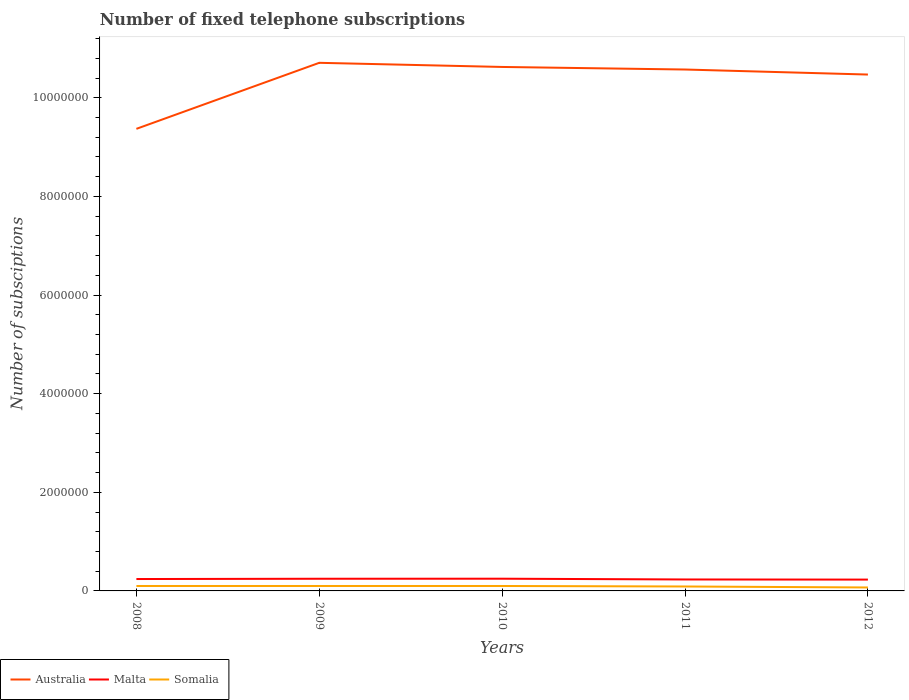How many different coloured lines are there?
Give a very brief answer. 3. Is the number of lines equal to the number of legend labels?
Make the answer very short. Yes. Across all years, what is the maximum number of fixed telephone subscriptions in Australia?
Provide a succinct answer. 9.37e+06. In which year was the number of fixed telephone subscriptions in Australia maximum?
Your response must be concise. 2008. What is the total number of fixed telephone subscriptions in Malta in the graph?
Keep it short and to the point. 1.72e+04. What is the difference between the highest and the second highest number of fixed telephone subscriptions in Malta?
Offer a terse response. 1.79e+04. What is the difference between the highest and the lowest number of fixed telephone subscriptions in Australia?
Your answer should be compact. 4. Is the number of fixed telephone subscriptions in Malta strictly greater than the number of fixed telephone subscriptions in Australia over the years?
Your response must be concise. Yes. How many years are there in the graph?
Make the answer very short. 5. What is the difference between two consecutive major ticks on the Y-axis?
Provide a short and direct response. 2.00e+06. Does the graph contain any zero values?
Your answer should be compact. No. What is the title of the graph?
Offer a very short reply. Number of fixed telephone subscriptions. What is the label or title of the X-axis?
Offer a terse response. Years. What is the label or title of the Y-axis?
Keep it short and to the point. Number of subsciptions. What is the Number of subsciptions in Australia in 2008?
Give a very brief answer. 9.37e+06. What is the Number of subsciptions in Malta in 2008?
Provide a succinct answer. 2.41e+05. What is the Number of subsciptions in Somalia in 2008?
Make the answer very short. 1.00e+05. What is the Number of subsciptions in Australia in 2009?
Ensure brevity in your answer.  1.07e+07. What is the Number of subsciptions in Malta in 2009?
Offer a terse response. 2.47e+05. What is the Number of subsciptions in Somalia in 2009?
Ensure brevity in your answer.  1.00e+05. What is the Number of subsciptions of Australia in 2010?
Your response must be concise. 1.06e+07. What is the Number of subsciptions in Malta in 2010?
Your answer should be very brief. 2.48e+05. What is the Number of subsciptions in Somalia in 2010?
Provide a succinct answer. 1.00e+05. What is the Number of subsciptions of Australia in 2011?
Provide a short and direct response. 1.06e+07. What is the Number of subsciptions in Malta in 2011?
Give a very brief answer. 2.32e+05. What is the Number of subsciptions of Australia in 2012?
Give a very brief answer. 1.05e+07. What is the Number of subsciptions of Malta in 2012?
Make the answer very short. 2.30e+05. What is the Number of subsciptions of Somalia in 2012?
Make the answer very short. 7.00e+04. Across all years, what is the maximum Number of subsciptions in Australia?
Provide a short and direct response. 1.07e+07. Across all years, what is the maximum Number of subsciptions of Malta?
Offer a very short reply. 2.48e+05. Across all years, what is the maximum Number of subsciptions of Somalia?
Offer a very short reply. 1.00e+05. Across all years, what is the minimum Number of subsciptions in Australia?
Keep it short and to the point. 9.37e+06. Across all years, what is the minimum Number of subsciptions of Malta?
Your response must be concise. 2.30e+05. What is the total Number of subsciptions in Australia in the graph?
Offer a terse response. 5.17e+07. What is the total Number of subsciptions of Malta in the graph?
Ensure brevity in your answer.  1.20e+06. What is the total Number of subsciptions in Somalia in the graph?
Your response must be concise. 4.60e+05. What is the difference between the Number of subsciptions in Australia in 2008 and that in 2009?
Provide a short and direct response. -1.34e+06. What is the difference between the Number of subsciptions in Malta in 2008 and that in 2009?
Offer a very short reply. -5775. What is the difference between the Number of subsciptions of Australia in 2008 and that in 2010?
Offer a very short reply. -1.26e+06. What is the difference between the Number of subsciptions of Malta in 2008 and that in 2010?
Make the answer very short. -6520. What is the difference between the Number of subsciptions in Australia in 2008 and that in 2011?
Offer a terse response. -1.20e+06. What is the difference between the Number of subsciptions of Malta in 2008 and that in 2011?
Your answer should be very brief. 8912. What is the difference between the Number of subsciptions of Somalia in 2008 and that in 2011?
Your answer should be very brief. 10000. What is the difference between the Number of subsciptions in Australia in 2008 and that in 2012?
Your answer should be very brief. -1.10e+06. What is the difference between the Number of subsciptions in Malta in 2008 and that in 2012?
Give a very brief answer. 1.14e+04. What is the difference between the Number of subsciptions of Somalia in 2008 and that in 2012?
Your response must be concise. 3.00e+04. What is the difference between the Number of subsciptions in Australia in 2009 and that in 2010?
Your answer should be compact. 8.40e+04. What is the difference between the Number of subsciptions in Malta in 2009 and that in 2010?
Provide a succinct answer. -745. What is the difference between the Number of subsciptions in Australia in 2009 and that in 2011?
Provide a succinct answer. 1.36e+05. What is the difference between the Number of subsciptions in Malta in 2009 and that in 2011?
Your response must be concise. 1.47e+04. What is the difference between the Number of subsciptions of Somalia in 2009 and that in 2011?
Give a very brief answer. 10000. What is the difference between the Number of subsciptions of Australia in 2009 and that in 2012?
Your answer should be compact. 2.38e+05. What is the difference between the Number of subsciptions of Malta in 2009 and that in 2012?
Keep it short and to the point. 1.72e+04. What is the difference between the Number of subsciptions in Australia in 2010 and that in 2011?
Offer a very short reply. 5.20e+04. What is the difference between the Number of subsciptions of Malta in 2010 and that in 2011?
Your answer should be compact. 1.54e+04. What is the difference between the Number of subsciptions in Australia in 2010 and that in 2012?
Provide a short and direct response. 1.54e+05. What is the difference between the Number of subsciptions of Malta in 2010 and that in 2012?
Your answer should be compact. 1.79e+04. What is the difference between the Number of subsciptions of Australia in 2011 and that in 2012?
Provide a succinct answer. 1.02e+05. What is the difference between the Number of subsciptions in Malta in 2011 and that in 2012?
Offer a very short reply. 2463. What is the difference between the Number of subsciptions in Australia in 2008 and the Number of subsciptions in Malta in 2009?
Provide a succinct answer. 9.12e+06. What is the difference between the Number of subsciptions of Australia in 2008 and the Number of subsciptions of Somalia in 2009?
Give a very brief answer. 9.27e+06. What is the difference between the Number of subsciptions of Malta in 2008 and the Number of subsciptions of Somalia in 2009?
Provide a short and direct response. 1.41e+05. What is the difference between the Number of subsciptions in Australia in 2008 and the Number of subsciptions in Malta in 2010?
Provide a short and direct response. 9.12e+06. What is the difference between the Number of subsciptions of Australia in 2008 and the Number of subsciptions of Somalia in 2010?
Your answer should be compact. 9.27e+06. What is the difference between the Number of subsciptions of Malta in 2008 and the Number of subsciptions of Somalia in 2010?
Provide a succinct answer. 1.41e+05. What is the difference between the Number of subsciptions in Australia in 2008 and the Number of subsciptions in Malta in 2011?
Give a very brief answer. 9.14e+06. What is the difference between the Number of subsciptions in Australia in 2008 and the Number of subsciptions in Somalia in 2011?
Offer a very short reply. 9.28e+06. What is the difference between the Number of subsciptions in Malta in 2008 and the Number of subsciptions in Somalia in 2011?
Your answer should be compact. 1.51e+05. What is the difference between the Number of subsciptions in Australia in 2008 and the Number of subsciptions in Malta in 2012?
Offer a very short reply. 9.14e+06. What is the difference between the Number of subsciptions in Australia in 2008 and the Number of subsciptions in Somalia in 2012?
Keep it short and to the point. 9.30e+06. What is the difference between the Number of subsciptions in Malta in 2008 and the Number of subsciptions in Somalia in 2012?
Your response must be concise. 1.71e+05. What is the difference between the Number of subsciptions of Australia in 2009 and the Number of subsciptions of Malta in 2010?
Provide a succinct answer. 1.05e+07. What is the difference between the Number of subsciptions in Australia in 2009 and the Number of subsciptions in Somalia in 2010?
Your response must be concise. 1.06e+07. What is the difference between the Number of subsciptions in Malta in 2009 and the Number of subsciptions in Somalia in 2010?
Your response must be concise. 1.47e+05. What is the difference between the Number of subsciptions of Australia in 2009 and the Number of subsciptions of Malta in 2011?
Keep it short and to the point. 1.05e+07. What is the difference between the Number of subsciptions of Australia in 2009 and the Number of subsciptions of Somalia in 2011?
Your answer should be compact. 1.06e+07. What is the difference between the Number of subsciptions of Malta in 2009 and the Number of subsciptions of Somalia in 2011?
Give a very brief answer. 1.57e+05. What is the difference between the Number of subsciptions in Australia in 2009 and the Number of subsciptions in Malta in 2012?
Provide a short and direct response. 1.05e+07. What is the difference between the Number of subsciptions in Australia in 2009 and the Number of subsciptions in Somalia in 2012?
Provide a short and direct response. 1.06e+07. What is the difference between the Number of subsciptions of Malta in 2009 and the Number of subsciptions of Somalia in 2012?
Provide a succinct answer. 1.77e+05. What is the difference between the Number of subsciptions of Australia in 2010 and the Number of subsciptions of Malta in 2011?
Provide a short and direct response. 1.04e+07. What is the difference between the Number of subsciptions of Australia in 2010 and the Number of subsciptions of Somalia in 2011?
Offer a terse response. 1.05e+07. What is the difference between the Number of subsciptions of Malta in 2010 and the Number of subsciptions of Somalia in 2011?
Your answer should be very brief. 1.58e+05. What is the difference between the Number of subsciptions in Australia in 2010 and the Number of subsciptions in Malta in 2012?
Ensure brevity in your answer.  1.04e+07. What is the difference between the Number of subsciptions in Australia in 2010 and the Number of subsciptions in Somalia in 2012?
Provide a succinct answer. 1.06e+07. What is the difference between the Number of subsciptions of Malta in 2010 and the Number of subsciptions of Somalia in 2012?
Give a very brief answer. 1.78e+05. What is the difference between the Number of subsciptions of Australia in 2011 and the Number of subsciptions of Malta in 2012?
Offer a terse response. 1.03e+07. What is the difference between the Number of subsciptions in Australia in 2011 and the Number of subsciptions in Somalia in 2012?
Your response must be concise. 1.05e+07. What is the difference between the Number of subsciptions of Malta in 2011 and the Number of subsciptions of Somalia in 2012?
Keep it short and to the point. 1.62e+05. What is the average Number of subsciptions of Australia per year?
Offer a very short reply. 1.03e+07. What is the average Number of subsciptions of Malta per year?
Provide a short and direct response. 2.40e+05. What is the average Number of subsciptions in Somalia per year?
Offer a very short reply. 9.20e+04. In the year 2008, what is the difference between the Number of subsciptions in Australia and Number of subsciptions in Malta?
Your answer should be very brief. 9.13e+06. In the year 2008, what is the difference between the Number of subsciptions in Australia and Number of subsciptions in Somalia?
Provide a succinct answer. 9.27e+06. In the year 2008, what is the difference between the Number of subsciptions of Malta and Number of subsciptions of Somalia?
Your response must be concise. 1.41e+05. In the year 2009, what is the difference between the Number of subsciptions in Australia and Number of subsciptions in Malta?
Offer a very short reply. 1.05e+07. In the year 2009, what is the difference between the Number of subsciptions in Australia and Number of subsciptions in Somalia?
Your answer should be very brief. 1.06e+07. In the year 2009, what is the difference between the Number of subsciptions of Malta and Number of subsciptions of Somalia?
Give a very brief answer. 1.47e+05. In the year 2010, what is the difference between the Number of subsciptions of Australia and Number of subsciptions of Malta?
Ensure brevity in your answer.  1.04e+07. In the year 2010, what is the difference between the Number of subsciptions in Australia and Number of subsciptions in Somalia?
Provide a short and direct response. 1.05e+07. In the year 2010, what is the difference between the Number of subsciptions in Malta and Number of subsciptions in Somalia?
Give a very brief answer. 1.48e+05. In the year 2011, what is the difference between the Number of subsciptions of Australia and Number of subsciptions of Malta?
Ensure brevity in your answer.  1.03e+07. In the year 2011, what is the difference between the Number of subsciptions in Australia and Number of subsciptions in Somalia?
Your response must be concise. 1.05e+07. In the year 2011, what is the difference between the Number of subsciptions in Malta and Number of subsciptions in Somalia?
Give a very brief answer. 1.42e+05. In the year 2012, what is the difference between the Number of subsciptions in Australia and Number of subsciptions in Malta?
Your answer should be compact. 1.02e+07. In the year 2012, what is the difference between the Number of subsciptions of Australia and Number of subsciptions of Somalia?
Offer a terse response. 1.04e+07. In the year 2012, what is the difference between the Number of subsciptions in Malta and Number of subsciptions in Somalia?
Provide a short and direct response. 1.60e+05. What is the ratio of the Number of subsciptions of Australia in 2008 to that in 2009?
Your response must be concise. 0.88. What is the ratio of the Number of subsciptions in Malta in 2008 to that in 2009?
Offer a very short reply. 0.98. What is the ratio of the Number of subsciptions in Somalia in 2008 to that in 2009?
Your answer should be very brief. 1. What is the ratio of the Number of subsciptions of Australia in 2008 to that in 2010?
Keep it short and to the point. 0.88. What is the ratio of the Number of subsciptions in Malta in 2008 to that in 2010?
Ensure brevity in your answer.  0.97. What is the ratio of the Number of subsciptions in Somalia in 2008 to that in 2010?
Give a very brief answer. 1. What is the ratio of the Number of subsciptions in Australia in 2008 to that in 2011?
Make the answer very short. 0.89. What is the ratio of the Number of subsciptions in Malta in 2008 to that in 2011?
Offer a very short reply. 1.04. What is the ratio of the Number of subsciptions in Somalia in 2008 to that in 2011?
Offer a terse response. 1.11. What is the ratio of the Number of subsciptions in Australia in 2008 to that in 2012?
Make the answer very short. 0.89. What is the ratio of the Number of subsciptions of Malta in 2008 to that in 2012?
Provide a short and direct response. 1.05. What is the ratio of the Number of subsciptions of Somalia in 2008 to that in 2012?
Give a very brief answer. 1.43. What is the ratio of the Number of subsciptions in Australia in 2009 to that in 2010?
Keep it short and to the point. 1.01. What is the ratio of the Number of subsciptions in Malta in 2009 to that in 2010?
Offer a terse response. 1. What is the ratio of the Number of subsciptions in Somalia in 2009 to that in 2010?
Provide a short and direct response. 1. What is the ratio of the Number of subsciptions in Australia in 2009 to that in 2011?
Make the answer very short. 1.01. What is the ratio of the Number of subsciptions in Malta in 2009 to that in 2011?
Ensure brevity in your answer.  1.06. What is the ratio of the Number of subsciptions in Australia in 2009 to that in 2012?
Your response must be concise. 1.02. What is the ratio of the Number of subsciptions in Malta in 2009 to that in 2012?
Keep it short and to the point. 1.07. What is the ratio of the Number of subsciptions in Somalia in 2009 to that in 2012?
Ensure brevity in your answer.  1.43. What is the ratio of the Number of subsciptions of Australia in 2010 to that in 2011?
Your answer should be compact. 1. What is the ratio of the Number of subsciptions of Malta in 2010 to that in 2011?
Keep it short and to the point. 1.07. What is the ratio of the Number of subsciptions in Australia in 2010 to that in 2012?
Provide a succinct answer. 1.01. What is the ratio of the Number of subsciptions in Malta in 2010 to that in 2012?
Give a very brief answer. 1.08. What is the ratio of the Number of subsciptions in Somalia in 2010 to that in 2012?
Your answer should be very brief. 1.43. What is the ratio of the Number of subsciptions of Australia in 2011 to that in 2012?
Your answer should be very brief. 1.01. What is the ratio of the Number of subsciptions of Malta in 2011 to that in 2012?
Your answer should be compact. 1.01. What is the ratio of the Number of subsciptions in Somalia in 2011 to that in 2012?
Your answer should be compact. 1.29. What is the difference between the highest and the second highest Number of subsciptions of Australia?
Provide a short and direct response. 8.40e+04. What is the difference between the highest and the second highest Number of subsciptions in Malta?
Provide a short and direct response. 745. What is the difference between the highest and the second highest Number of subsciptions of Somalia?
Keep it short and to the point. 0. What is the difference between the highest and the lowest Number of subsciptions in Australia?
Provide a short and direct response. 1.34e+06. What is the difference between the highest and the lowest Number of subsciptions of Malta?
Keep it short and to the point. 1.79e+04. What is the difference between the highest and the lowest Number of subsciptions of Somalia?
Your response must be concise. 3.00e+04. 